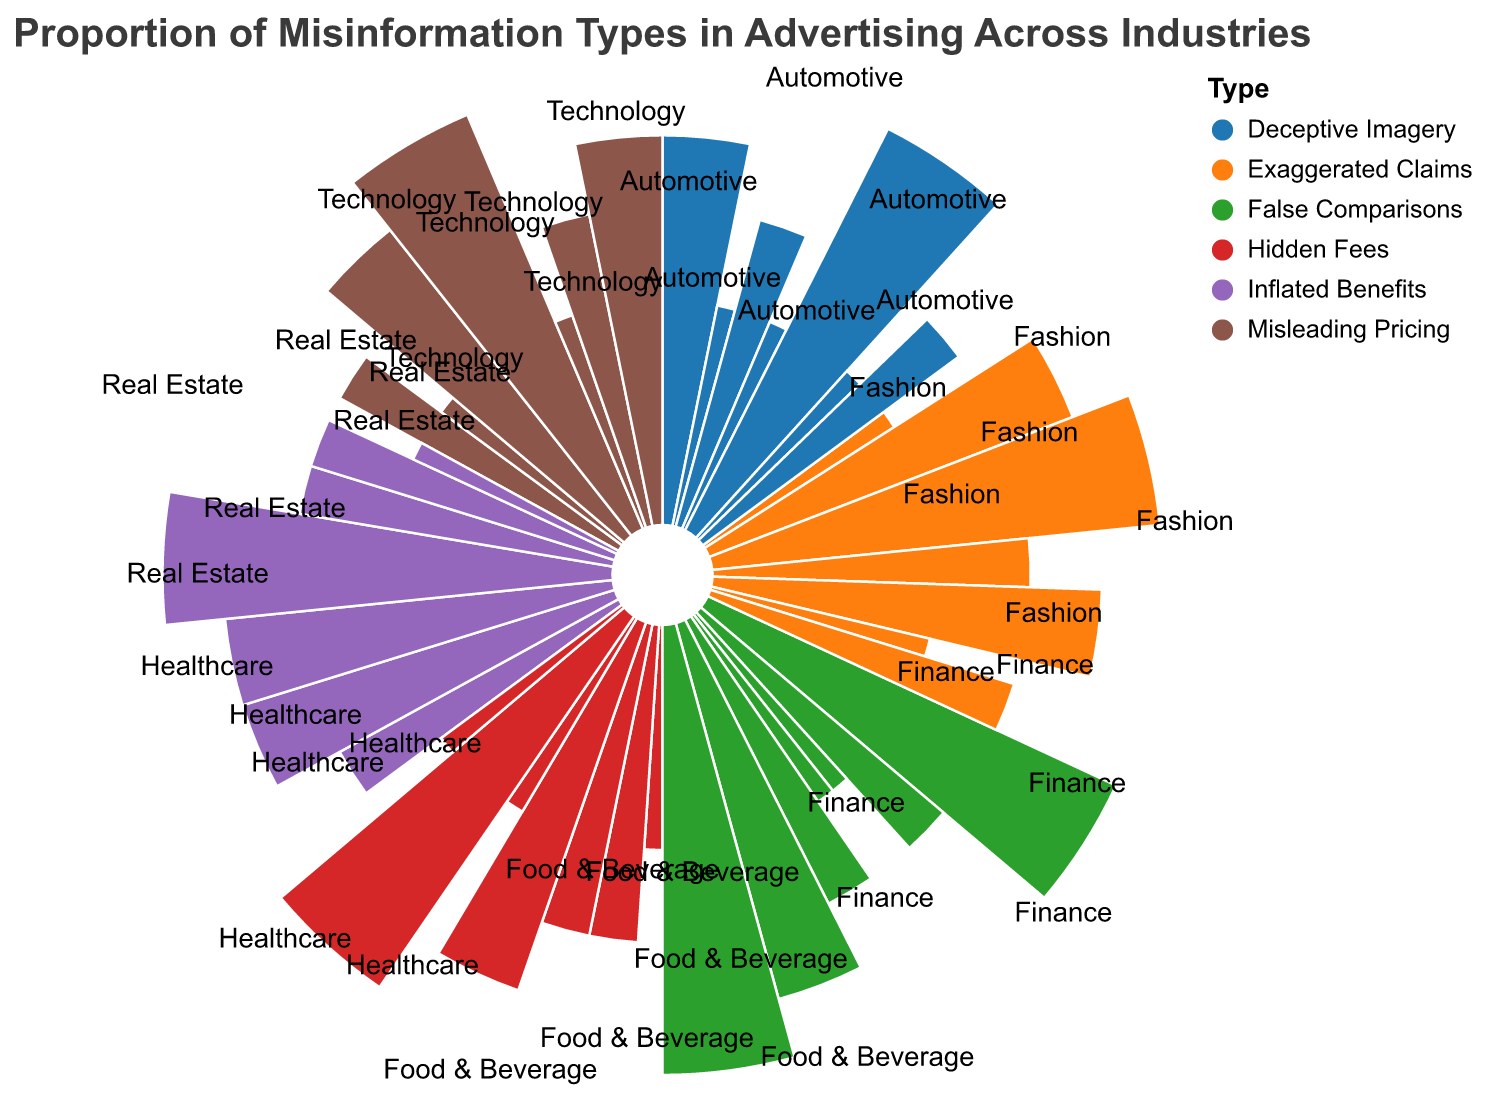What is the title of the polar chart? The title of the chart is usually displayed at the top, which helps in understanding what the chart is about.
Answer: Proportion of Misinformation Types in Advertising Across Industries Which industry has the highest proportion of "Exaggerated Claims"? To find this, identify the segment labeled "Exaggerated Claims" for each industry and compare their sizes.
Answer: Healthcare How many industries have "Misleading Pricing" as one of their misinformation types? Count the number of segments labeled "Misleading Pricing" across all industries.
Answer: 7 Which industry has the same proportion (10) of "Hidden Fees" and "Deceptive Imagery"? Identify the industry that shows segments with the value 10 for both "Hidden Fees" and "Deceptive Imagery."
Answer: Technology Is the proportion of "False Comparisons" greater in the Automotive industry or the Finance industry? Compare the sizes of the "False Comparisons" segments for Automotive and Finance industries.
Answer: Automotive What is the combined proportion of "Inflated Benefits" in Healthcare and Food & Beverage industries? Sum the values of "Inflated Benefits" for Healthcare and Food & Beverage industries.
Answer: 35 Which industry has the smallest proportion of "Hidden Fees"? Identify the smallest segment labeled "Hidden Fees" among all the industries.
Answer: Fashion, Real Estate, Automotive (all have 5) What is the average proportion of "False Comparisons" across all industries? Add the proportions of "False Comparisons" for all industries and divide by the number of industries (7).
Answer: (20+10+5+5+10+15+20)/7 = 12.14 Between the Technology and Fashion industries, which one has a larger proportion of "Deceptive Imagery"? Compare the "Deceptive Imagery" segments for Technology and Fashion industries.
Answer: Fashion Which industry has the highest variety in misinformation types, considering different proportions for different types? The industry with the most diverse set of segment sizes for each misinformation type will have the highest variety.
Answer: Food & Beverage 